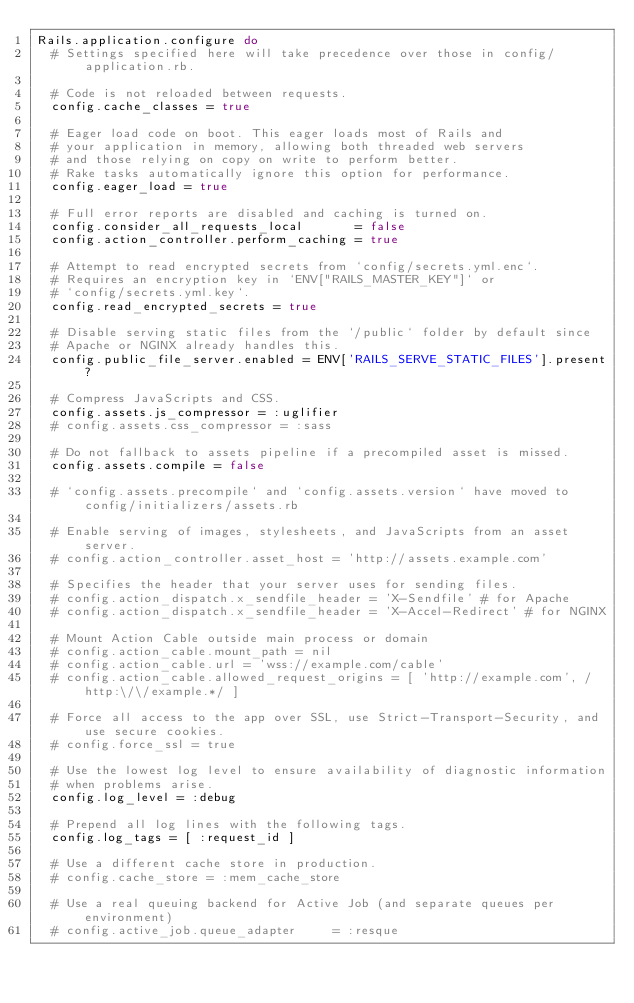Convert code to text. <code><loc_0><loc_0><loc_500><loc_500><_Ruby_>Rails.application.configure do
  # Settings specified here will take precedence over those in config/application.rb.

  # Code is not reloaded between requests.
  config.cache_classes = true

  # Eager load code on boot. This eager loads most of Rails and
  # your application in memory, allowing both threaded web servers
  # and those relying on copy on write to perform better.
  # Rake tasks automatically ignore this option for performance.
  config.eager_load = true

  # Full error reports are disabled and caching is turned on.
  config.consider_all_requests_local       = false
  config.action_controller.perform_caching = true

  # Attempt to read encrypted secrets from `config/secrets.yml.enc`.
  # Requires an encryption key in `ENV["RAILS_MASTER_KEY"]` or
  # `config/secrets.yml.key`.
  config.read_encrypted_secrets = true

  # Disable serving static files from the `/public` folder by default since
  # Apache or NGINX already handles this.
  config.public_file_server.enabled = ENV['RAILS_SERVE_STATIC_FILES'].present?

  # Compress JavaScripts and CSS.
  config.assets.js_compressor = :uglifier
  # config.assets.css_compressor = :sass

  # Do not fallback to assets pipeline if a precompiled asset is missed.
  config.assets.compile = false

  # `config.assets.precompile` and `config.assets.version` have moved to config/initializers/assets.rb

  # Enable serving of images, stylesheets, and JavaScripts from an asset server.
  # config.action_controller.asset_host = 'http://assets.example.com'

  # Specifies the header that your server uses for sending files.
  # config.action_dispatch.x_sendfile_header = 'X-Sendfile' # for Apache
  # config.action_dispatch.x_sendfile_header = 'X-Accel-Redirect' # for NGINX

  # Mount Action Cable outside main process or domain
  # config.action_cable.mount_path = nil
  # config.action_cable.url = 'wss://example.com/cable'
  # config.action_cable.allowed_request_origins = [ 'http://example.com', /http:\/\/example.*/ ]

  # Force all access to the app over SSL, use Strict-Transport-Security, and use secure cookies.
  # config.force_ssl = true

  # Use the lowest log level to ensure availability of diagnostic information
  # when problems arise.
  config.log_level = :debug

  # Prepend all log lines with the following tags.
  config.log_tags = [ :request_id ]

  # Use a different cache store in production.
  # config.cache_store = :mem_cache_store

  # Use a real queuing backend for Active Job (and separate queues per environment)
  # config.active_job.queue_adapter     = :resque</code> 